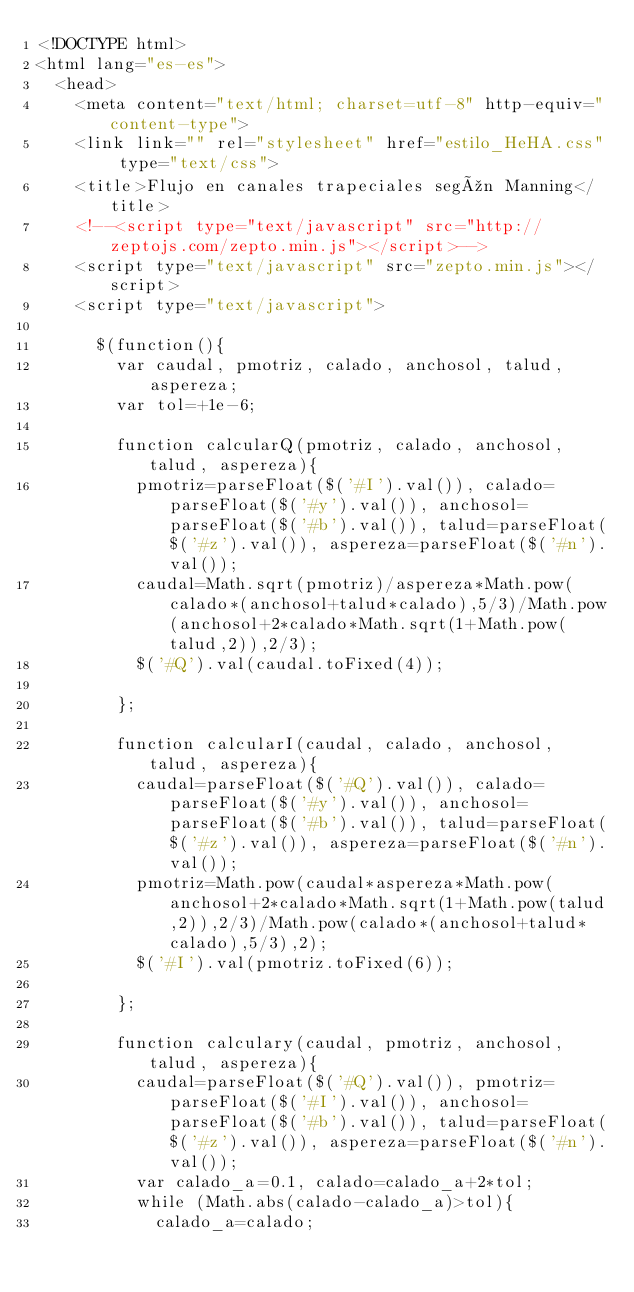Convert code to text. <code><loc_0><loc_0><loc_500><loc_500><_HTML_><!DOCTYPE html>
<html lang="es-es">
  <head>
    <meta content="text/html; charset=utf-8" http-equiv="content-type">
    <link link="" rel="stylesheet" href="estilo_HeHA.css" type="text/css">
    <title>Flujo en canales trapeciales según Manning</title>
    <!--<script type="text/javascript" src="http://zeptojs.com/zepto.min.js"></script>-->
    <script type="text/javascript" src="zepto.min.js"></script>
    <script type="text/javascript">
      
      $(function(){
        var caudal, pmotriz, calado, anchosol, talud, aspereza;
        var tol=+1e-6;
                
        function calcularQ(pmotriz, calado, anchosol, talud, aspereza){
          pmotriz=parseFloat($('#I').val()), calado=parseFloat($('#y').val()), anchosol=parseFloat($('#b').val()), talud=parseFloat($('#z').val()), aspereza=parseFloat($('#n').val());
          caudal=Math.sqrt(pmotriz)/aspereza*Math.pow(calado*(anchosol+talud*calado),5/3)/Math.pow(anchosol+2*calado*Math.sqrt(1+Math.pow(talud,2)),2/3);
          $('#Q').val(caudal.toFixed(4));
          
        };
        
        function calcularI(caudal, calado, anchosol, talud, aspereza){
          caudal=parseFloat($('#Q').val()), calado=parseFloat($('#y').val()), anchosol=parseFloat($('#b').val()), talud=parseFloat($('#z').val()), aspereza=parseFloat($('#n').val());
          pmotriz=Math.pow(caudal*aspereza*Math.pow(anchosol+2*calado*Math.sqrt(1+Math.pow(talud,2)),2/3)/Math.pow(calado*(anchosol+talud*calado),5/3),2);
          $('#I').val(pmotriz.toFixed(6));
        
        };
        
        function calculary(caudal, pmotriz, anchosol, talud, aspereza){
          caudal=parseFloat($('#Q').val()), pmotriz=parseFloat($('#I').val()), anchosol=parseFloat($('#b').val()), talud=parseFloat($('#z').val()), aspereza=parseFloat($('#n').val());
          var calado_a=0.1, calado=calado_a+2*tol;
          while (Math.abs(calado-calado_a)>tol){
            calado_a=calado;</code> 